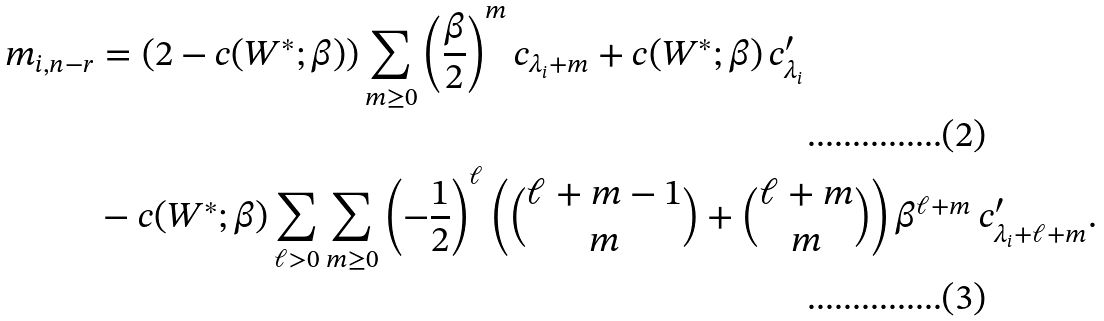Convert formula to latex. <formula><loc_0><loc_0><loc_500><loc_500>m _ { i , n - r } & = \left ( 2 - c ( W ^ { * } ; \beta ) \right ) \sum _ { m \geq 0 } \left ( \frac { \beta } { 2 } \right ) ^ { m } c _ { \lambda _ { i } + m } + c ( W ^ { * } ; \beta ) \, c ^ { \prime } _ { \lambda _ { i } } \\ & - c ( W ^ { * } ; \beta ) \sum _ { \ell > 0 } \sum _ { m \geq 0 } \left ( - \frac { 1 } { 2 } \right ) ^ { \ell } \left ( \binom { \ell + m - 1 } { m } + \binom { \ell + m } { m } \right ) \beta ^ { \ell + m } \, c ^ { \prime } _ { \lambda _ { i } + \ell + m } .</formula> 